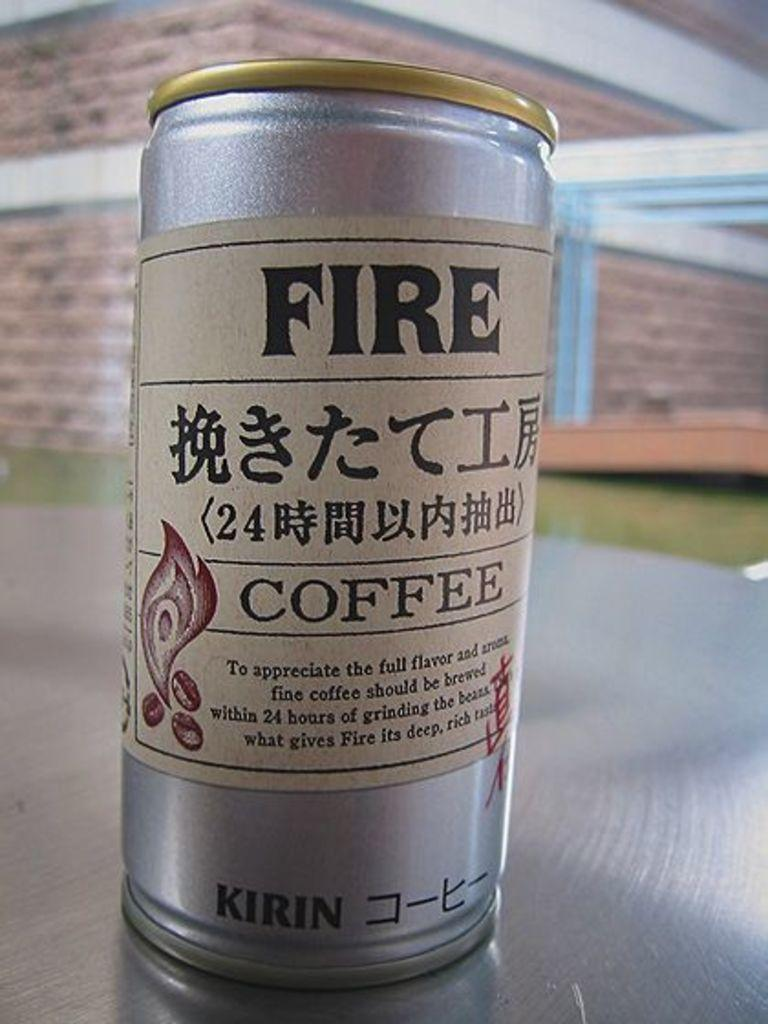<image>
Render a clear and concise summary of the photo. A silver can of Fire coffee by Kirin is placed on a table. 